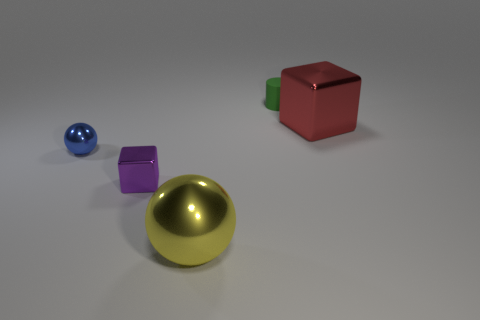There is a cube that is in front of the blue metal object; is it the same size as the yellow thing?
Offer a terse response. No. What is the size of the object that is in front of the rubber object and behind the small sphere?
Your answer should be compact. Large. How many metal things have the same size as the yellow shiny ball?
Keep it short and to the point. 1. There is a metal ball that is behind the small purple shiny cube; what number of red metal blocks are left of it?
Ensure brevity in your answer.  0. Does the metallic cube behind the small blue shiny sphere have the same color as the tiny rubber thing?
Offer a very short reply. No. There is a large object to the left of the big cube behind the small blue ball; is there a big yellow metal ball that is behind it?
Provide a short and direct response. No. What shape is the small object that is behind the small purple cube and in front of the tiny green rubber cylinder?
Offer a very short reply. Sphere. Is there a big object that has the same color as the tiny matte cylinder?
Make the answer very short. No. What is the color of the shiny cube to the right of the small matte thing that is behind the blue metal sphere?
Provide a short and direct response. Red. There is a red block that is right of the metal block to the left of the green matte object behind the large cube; what size is it?
Your answer should be compact. Large. 